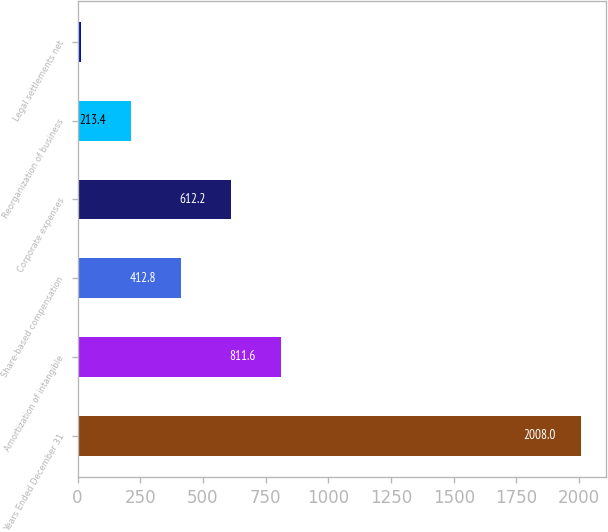Convert chart to OTSL. <chart><loc_0><loc_0><loc_500><loc_500><bar_chart><fcel>Years Ended December 31<fcel>Amortization of intangible<fcel>Share-based compensation<fcel>Corporate expenses<fcel>Reorganization of business<fcel>Legal settlements net<nl><fcel>2008<fcel>811.6<fcel>412.8<fcel>612.2<fcel>213.4<fcel>14<nl></chart> 